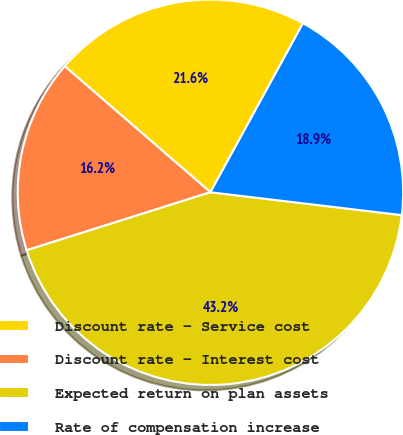<chart> <loc_0><loc_0><loc_500><loc_500><pie_chart><fcel>Discount rate - Service cost<fcel>Discount rate - Interest cost<fcel>Expected return on plan assets<fcel>Rate of compensation increase<nl><fcel>21.62%<fcel>16.22%<fcel>43.24%<fcel>18.92%<nl></chart> 